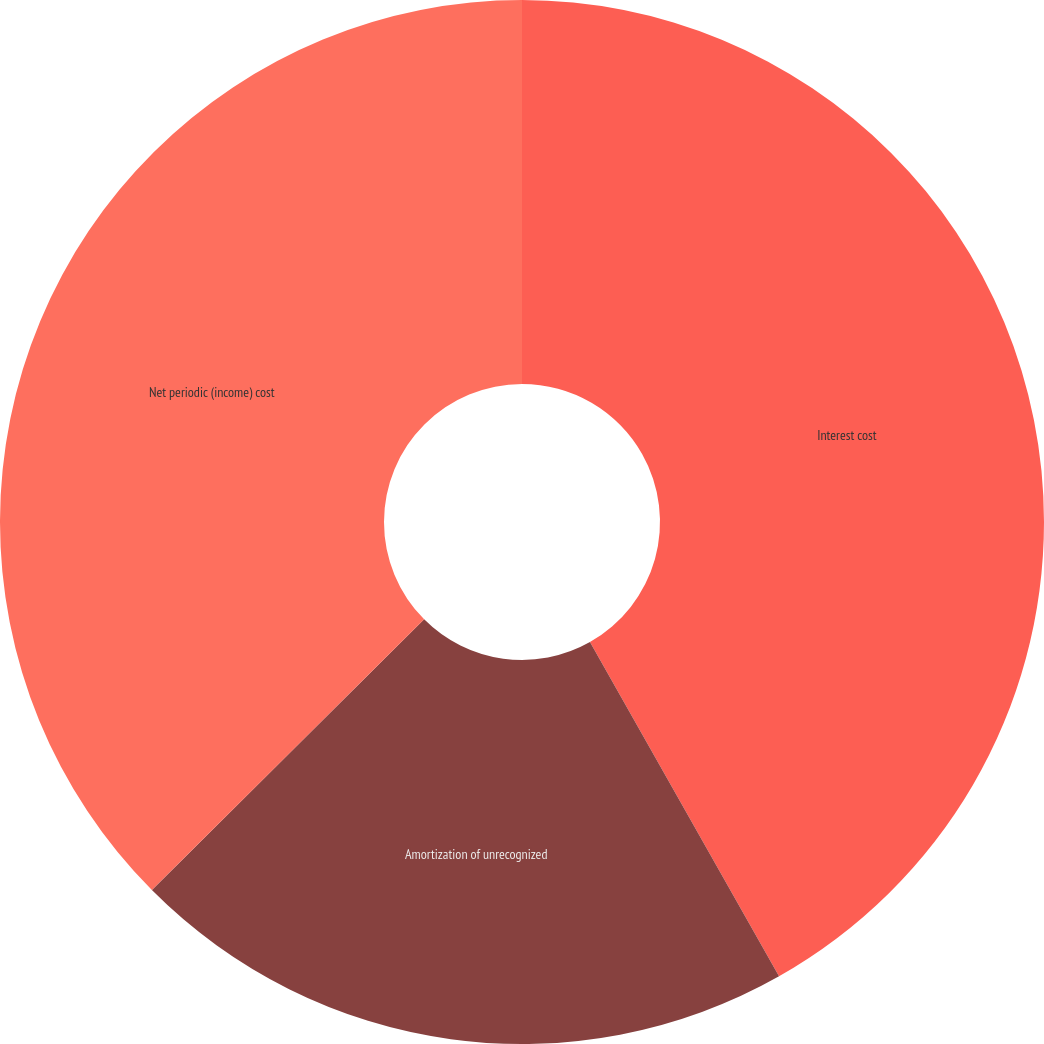Convert chart to OTSL. <chart><loc_0><loc_0><loc_500><loc_500><pie_chart><fcel>Interest cost<fcel>Amortization of unrecognized<fcel>Net periodic (income) cost<nl><fcel>41.81%<fcel>20.74%<fcel>37.46%<nl></chart> 